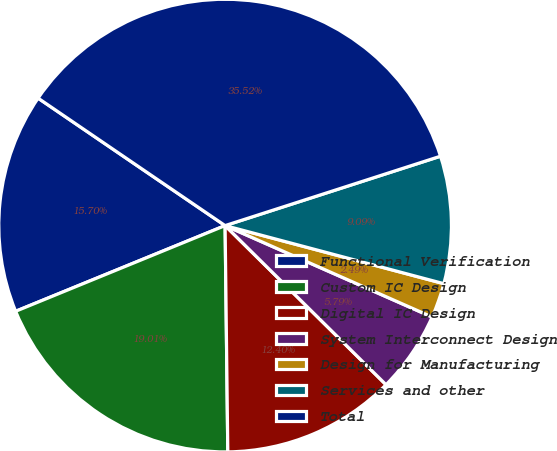Convert chart to OTSL. <chart><loc_0><loc_0><loc_500><loc_500><pie_chart><fcel>Functional Verification<fcel>Custom IC Design<fcel>Digital IC Design<fcel>System Interconnect Design<fcel>Design for Manufacturing<fcel>Services and other<fcel>Total<nl><fcel>15.7%<fcel>19.01%<fcel>12.4%<fcel>5.79%<fcel>2.49%<fcel>9.09%<fcel>35.52%<nl></chart> 